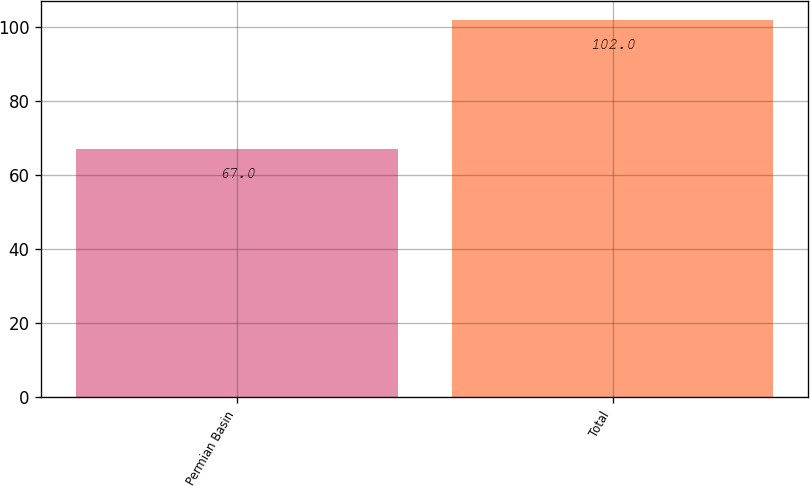Convert chart. <chart><loc_0><loc_0><loc_500><loc_500><bar_chart><fcel>Permian Basin<fcel>Total<nl><fcel>67<fcel>102<nl></chart> 